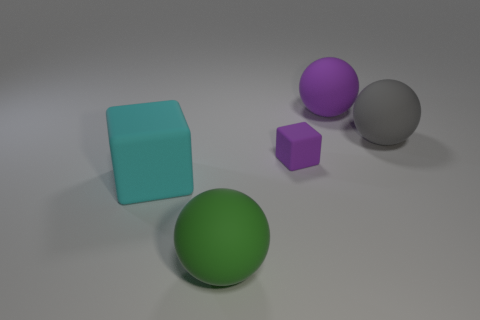Add 2 cyan matte blocks. How many objects exist? 7 Subtract all spheres. How many objects are left? 2 Add 3 cyan matte blocks. How many cyan matte blocks are left? 4 Add 2 green rubber things. How many green rubber things exist? 3 Subtract 0 red spheres. How many objects are left? 5 Subtract all tiny cyan metal blocks. Subtract all big blocks. How many objects are left? 4 